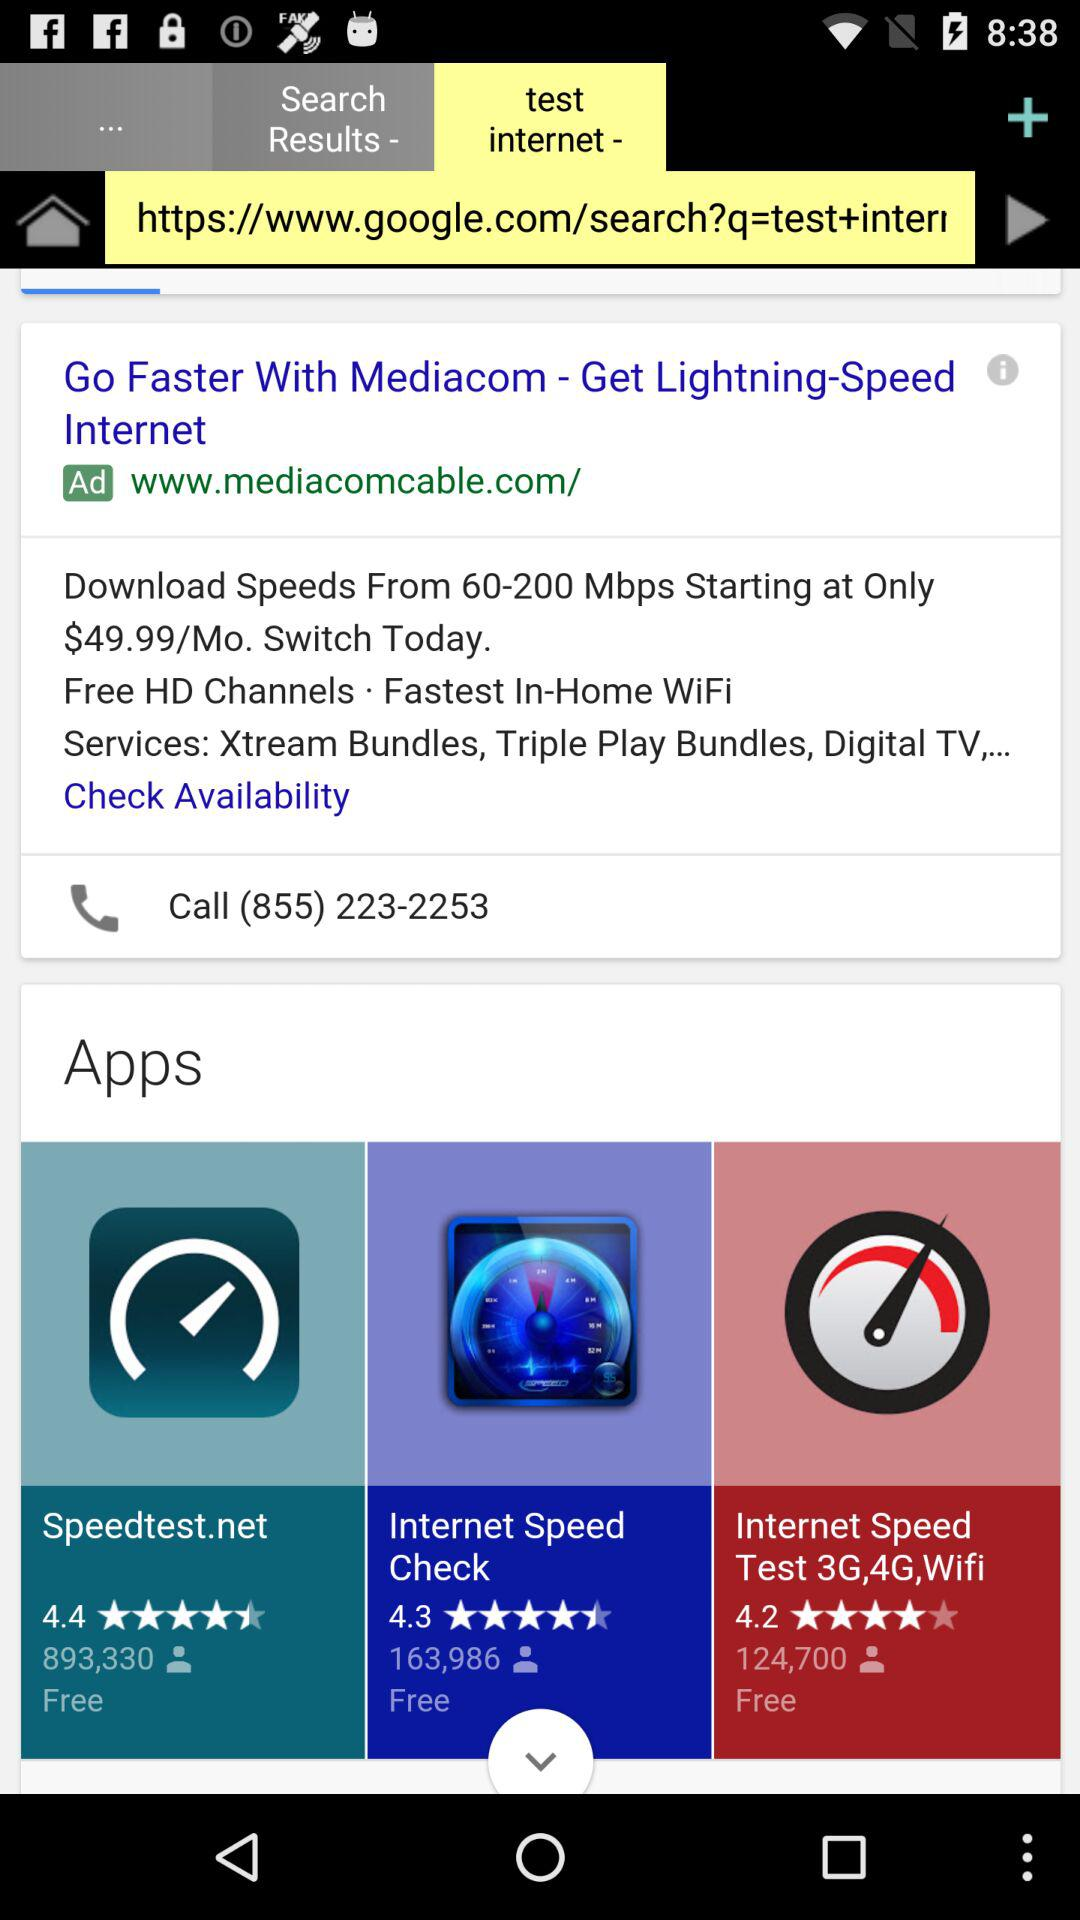What is the rating for "Speedtest.net"? The rating for "Speedtest.net" is 4.4. 